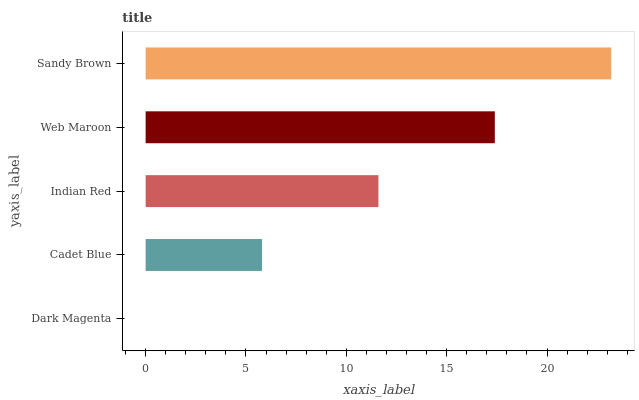Is Dark Magenta the minimum?
Answer yes or no. Yes. Is Sandy Brown the maximum?
Answer yes or no. Yes. Is Cadet Blue the minimum?
Answer yes or no. No. Is Cadet Blue the maximum?
Answer yes or no. No. Is Cadet Blue greater than Dark Magenta?
Answer yes or no. Yes. Is Dark Magenta less than Cadet Blue?
Answer yes or no. Yes. Is Dark Magenta greater than Cadet Blue?
Answer yes or no. No. Is Cadet Blue less than Dark Magenta?
Answer yes or no. No. Is Indian Red the high median?
Answer yes or no. Yes. Is Indian Red the low median?
Answer yes or no. Yes. Is Web Maroon the high median?
Answer yes or no. No. Is Web Maroon the low median?
Answer yes or no. No. 